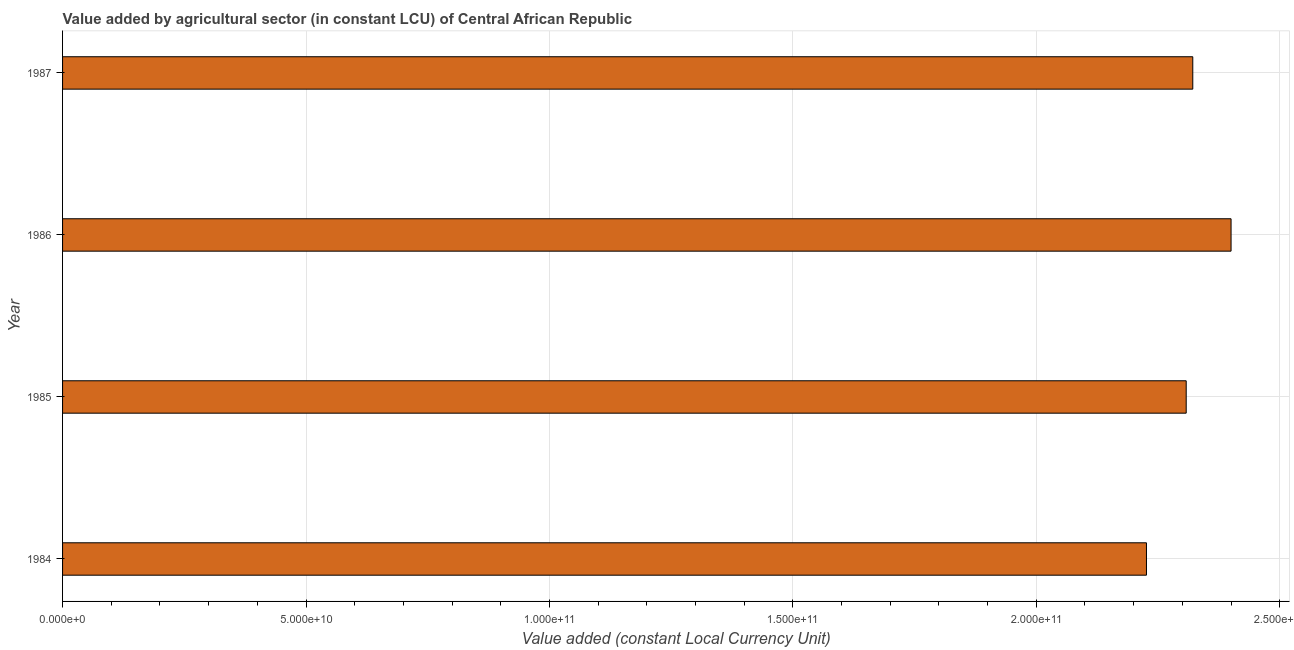Does the graph contain grids?
Your response must be concise. Yes. What is the title of the graph?
Offer a very short reply. Value added by agricultural sector (in constant LCU) of Central African Republic. What is the label or title of the X-axis?
Make the answer very short. Value added (constant Local Currency Unit). What is the label or title of the Y-axis?
Make the answer very short. Year. What is the value added by agriculture sector in 1987?
Offer a terse response. 2.32e+11. Across all years, what is the maximum value added by agriculture sector?
Your answer should be compact. 2.40e+11. Across all years, what is the minimum value added by agriculture sector?
Keep it short and to the point. 2.23e+11. In which year was the value added by agriculture sector minimum?
Ensure brevity in your answer.  1984. What is the sum of the value added by agriculture sector?
Give a very brief answer. 9.26e+11. What is the difference between the value added by agriculture sector in 1984 and 1987?
Provide a short and direct response. -9.51e+09. What is the average value added by agriculture sector per year?
Give a very brief answer. 2.31e+11. What is the median value added by agriculture sector?
Your response must be concise. 2.31e+11. Do a majority of the years between 1986 and 1985 (inclusive) have value added by agriculture sector greater than 230000000000 LCU?
Provide a succinct answer. No. Is the value added by agriculture sector in 1985 less than that in 1986?
Your answer should be compact. Yes. Is the difference between the value added by agriculture sector in 1984 and 1987 greater than the difference between any two years?
Your answer should be compact. No. What is the difference between the highest and the second highest value added by agriculture sector?
Offer a very short reply. 7.86e+09. What is the difference between the highest and the lowest value added by agriculture sector?
Your response must be concise. 1.74e+1. How many years are there in the graph?
Give a very brief answer. 4. Are the values on the major ticks of X-axis written in scientific E-notation?
Make the answer very short. Yes. What is the Value added (constant Local Currency Unit) of 1984?
Make the answer very short. 2.23e+11. What is the Value added (constant Local Currency Unit) in 1985?
Your response must be concise. 2.31e+11. What is the Value added (constant Local Currency Unit) in 1986?
Keep it short and to the point. 2.40e+11. What is the Value added (constant Local Currency Unit) of 1987?
Provide a succinct answer. 2.32e+11. What is the difference between the Value added (constant Local Currency Unit) in 1984 and 1985?
Provide a short and direct response. -8.16e+09. What is the difference between the Value added (constant Local Currency Unit) in 1984 and 1986?
Provide a short and direct response. -1.74e+1. What is the difference between the Value added (constant Local Currency Unit) in 1984 and 1987?
Ensure brevity in your answer.  -9.51e+09. What is the difference between the Value added (constant Local Currency Unit) in 1985 and 1986?
Your response must be concise. -9.22e+09. What is the difference between the Value added (constant Local Currency Unit) in 1985 and 1987?
Make the answer very short. -1.35e+09. What is the difference between the Value added (constant Local Currency Unit) in 1986 and 1987?
Your answer should be very brief. 7.86e+09. What is the ratio of the Value added (constant Local Currency Unit) in 1984 to that in 1986?
Keep it short and to the point. 0.93. What is the ratio of the Value added (constant Local Currency Unit) in 1985 to that in 1986?
Your response must be concise. 0.96. What is the ratio of the Value added (constant Local Currency Unit) in 1986 to that in 1987?
Ensure brevity in your answer.  1.03. 